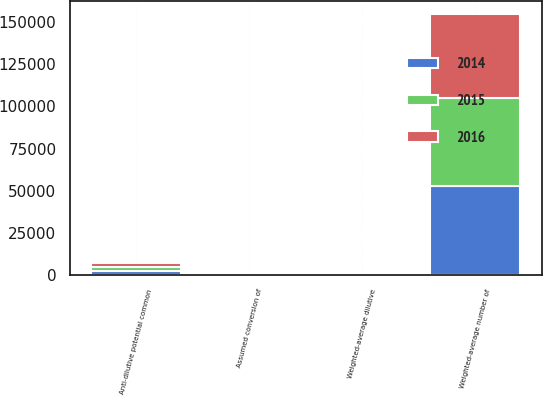Convert chart. <chart><loc_0><loc_0><loc_500><loc_500><stacked_bar_chart><ecel><fcel>Weighted-average number of<fcel>Weighted-average dilutive<fcel>Assumed conversion of<fcel>Anti-dilutive potential common<nl><fcel>2016<fcel>50063<fcel>238<fcel>334<fcel>2443<nl><fcel>2015<fcel>51593<fcel>395<fcel>258<fcel>2563<nl><fcel>2014<fcel>53023<fcel>340<fcel>382<fcel>2574<nl></chart> 